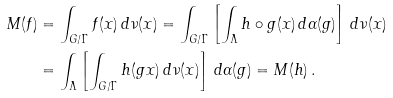<formula> <loc_0><loc_0><loc_500><loc_500>M ( f ) & = \int _ { G / \Gamma } f ( x ) \, { d } \nu ( x ) = \int _ { G / \Gamma } \left [ \int _ { \Lambda } h \circ g ( x ) \, { d } \alpha ( g ) \right ] \, { d } \nu ( x ) \\ & = \int _ { \Lambda } \left [ \int _ { G / \Gamma } h ( g x ) \, { d } \nu ( x ) \right ] \, { d } \alpha ( g ) = M ( h ) \, .</formula> 